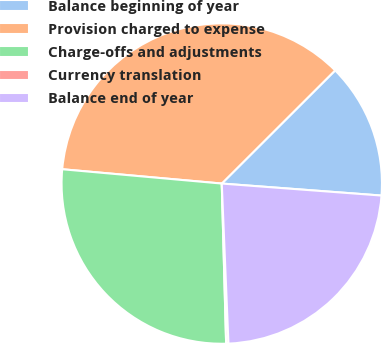Convert chart. <chart><loc_0><loc_0><loc_500><loc_500><pie_chart><fcel>Balance beginning of year<fcel>Provision charged to expense<fcel>Charge-offs and adjustments<fcel>Currency translation<fcel>Balance end of year<nl><fcel>13.68%<fcel>36.09%<fcel>26.86%<fcel>0.23%<fcel>23.14%<nl></chart> 